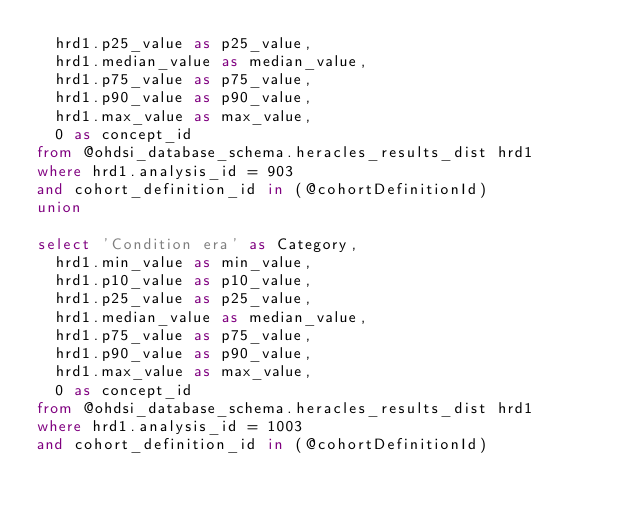<code> <loc_0><loc_0><loc_500><loc_500><_SQL_>	hrd1.p25_value as p25_value,
	hrd1.median_value as median_value,
	hrd1.p75_value as p75_value,
	hrd1.p90_value as p90_value,
	hrd1.max_value as max_value,
	0 as concept_id
from @ohdsi_database_schema.heracles_results_dist hrd1
where hrd1.analysis_id = 903
and cohort_definition_id in (@cohortDefinitionId)
union

select 'Condition era' as Category,
	hrd1.min_value as min_value,
	hrd1.p10_value as p10_value,
	hrd1.p25_value as p25_value,
	hrd1.median_value as median_value,
	hrd1.p75_value as p75_value,
	hrd1.p90_value as p90_value,
	hrd1.max_value as max_value,
	0 as concept_id
from @ohdsi_database_schema.heracles_results_dist hrd1
where hrd1.analysis_id = 1003
and cohort_definition_id in (@cohortDefinitionId)

</code> 